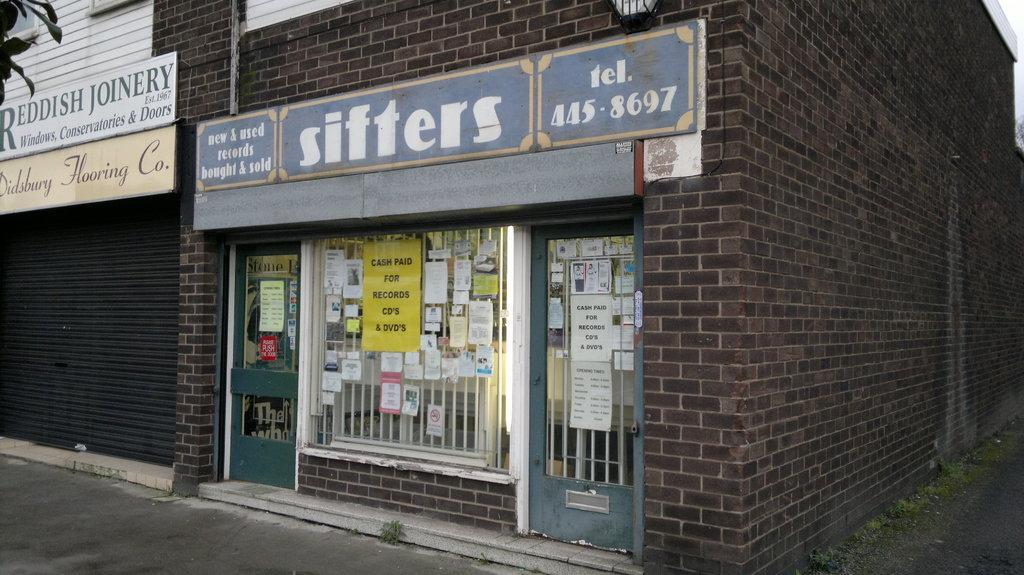In one or two sentences, can you explain what this image depicts? In this image we can see a building, there are some boards with some text on it, there are some posters, and papers with some text on it, are on the windows and a door, there is a light, leaves, and a shutter. 